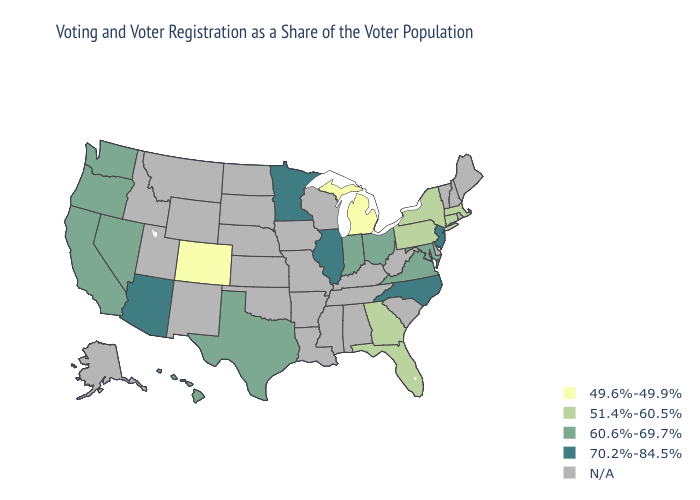What is the value of Michigan?
Answer briefly. 49.6%-49.9%. Name the states that have a value in the range N/A?
Keep it brief. Alabama, Alaska, Arkansas, Delaware, Idaho, Iowa, Kansas, Kentucky, Louisiana, Maine, Mississippi, Missouri, Montana, Nebraska, New Hampshire, New Mexico, North Dakota, Oklahoma, Rhode Island, South Carolina, South Dakota, Tennessee, Utah, Vermont, West Virginia, Wisconsin, Wyoming. What is the highest value in the South ?
Keep it brief. 70.2%-84.5%. Does the first symbol in the legend represent the smallest category?
Answer briefly. Yes. Name the states that have a value in the range 51.4%-60.5%?
Quick response, please. Connecticut, Florida, Georgia, Massachusetts, New York, Pennsylvania. What is the highest value in states that border South Dakota?
Quick response, please. 70.2%-84.5%. What is the lowest value in the USA?
Keep it brief. 49.6%-49.9%. What is the value of Colorado?
Answer briefly. 49.6%-49.9%. How many symbols are there in the legend?
Keep it brief. 5. What is the value of Rhode Island?
Quick response, please. N/A. What is the value of Massachusetts?
Quick response, please. 51.4%-60.5%. Name the states that have a value in the range N/A?
Write a very short answer. Alabama, Alaska, Arkansas, Delaware, Idaho, Iowa, Kansas, Kentucky, Louisiana, Maine, Mississippi, Missouri, Montana, Nebraska, New Hampshire, New Mexico, North Dakota, Oklahoma, Rhode Island, South Carolina, South Dakota, Tennessee, Utah, Vermont, West Virginia, Wisconsin, Wyoming. Name the states that have a value in the range 70.2%-84.5%?
Give a very brief answer. Arizona, Illinois, Minnesota, New Jersey, North Carolina. Does California have the highest value in the West?
Write a very short answer. No. 